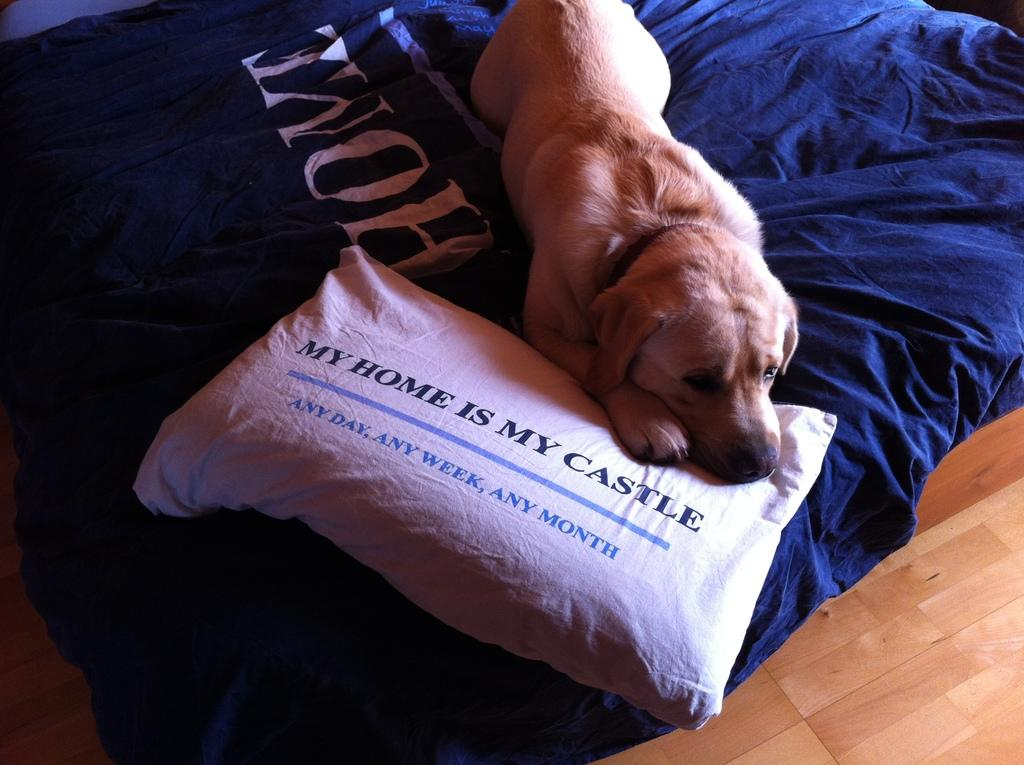What type of furniture is present in the image? There is a bed in the image. What is placed on the bed in the image? There is a pillow on the bed in the image. What type of animal can be seen in the image? There is a dog in the image. What part of the room is visible in the image? The floor is visible in the image. How does the dog use the tramp in the image? There is no tramp present in the image. What type of rest is the son taking in the image? There is no son present in the image. 